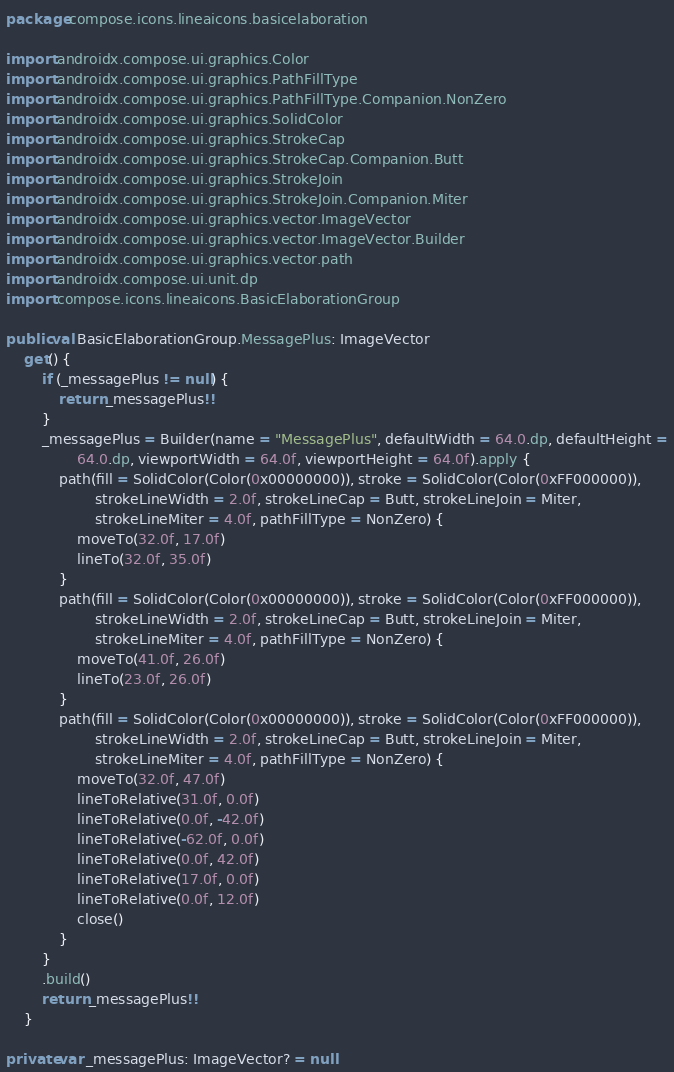Convert code to text. <code><loc_0><loc_0><loc_500><loc_500><_Kotlin_>package compose.icons.lineaicons.basicelaboration

import androidx.compose.ui.graphics.Color
import androidx.compose.ui.graphics.PathFillType
import androidx.compose.ui.graphics.PathFillType.Companion.NonZero
import androidx.compose.ui.graphics.SolidColor
import androidx.compose.ui.graphics.StrokeCap
import androidx.compose.ui.graphics.StrokeCap.Companion.Butt
import androidx.compose.ui.graphics.StrokeJoin
import androidx.compose.ui.graphics.StrokeJoin.Companion.Miter
import androidx.compose.ui.graphics.vector.ImageVector
import androidx.compose.ui.graphics.vector.ImageVector.Builder
import androidx.compose.ui.graphics.vector.path
import androidx.compose.ui.unit.dp
import compose.icons.lineaicons.BasicElaborationGroup

public val BasicElaborationGroup.MessagePlus: ImageVector
    get() {
        if (_messagePlus != null) {
            return _messagePlus!!
        }
        _messagePlus = Builder(name = "MessagePlus", defaultWidth = 64.0.dp, defaultHeight =
                64.0.dp, viewportWidth = 64.0f, viewportHeight = 64.0f).apply {
            path(fill = SolidColor(Color(0x00000000)), stroke = SolidColor(Color(0xFF000000)),
                    strokeLineWidth = 2.0f, strokeLineCap = Butt, strokeLineJoin = Miter,
                    strokeLineMiter = 4.0f, pathFillType = NonZero) {
                moveTo(32.0f, 17.0f)
                lineTo(32.0f, 35.0f)
            }
            path(fill = SolidColor(Color(0x00000000)), stroke = SolidColor(Color(0xFF000000)),
                    strokeLineWidth = 2.0f, strokeLineCap = Butt, strokeLineJoin = Miter,
                    strokeLineMiter = 4.0f, pathFillType = NonZero) {
                moveTo(41.0f, 26.0f)
                lineTo(23.0f, 26.0f)
            }
            path(fill = SolidColor(Color(0x00000000)), stroke = SolidColor(Color(0xFF000000)),
                    strokeLineWidth = 2.0f, strokeLineCap = Butt, strokeLineJoin = Miter,
                    strokeLineMiter = 4.0f, pathFillType = NonZero) {
                moveTo(32.0f, 47.0f)
                lineToRelative(31.0f, 0.0f)
                lineToRelative(0.0f, -42.0f)
                lineToRelative(-62.0f, 0.0f)
                lineToRelative(0.0f, 42.0f)
                lineToRelative(17.0f, 0.0f)
                lineToRelative(0.0f, 12.0f)
                close()
            }
        }
        .build()
        return _messagePlus!!
    }

private var _messagePlus: ImageVector? = null
</code> 